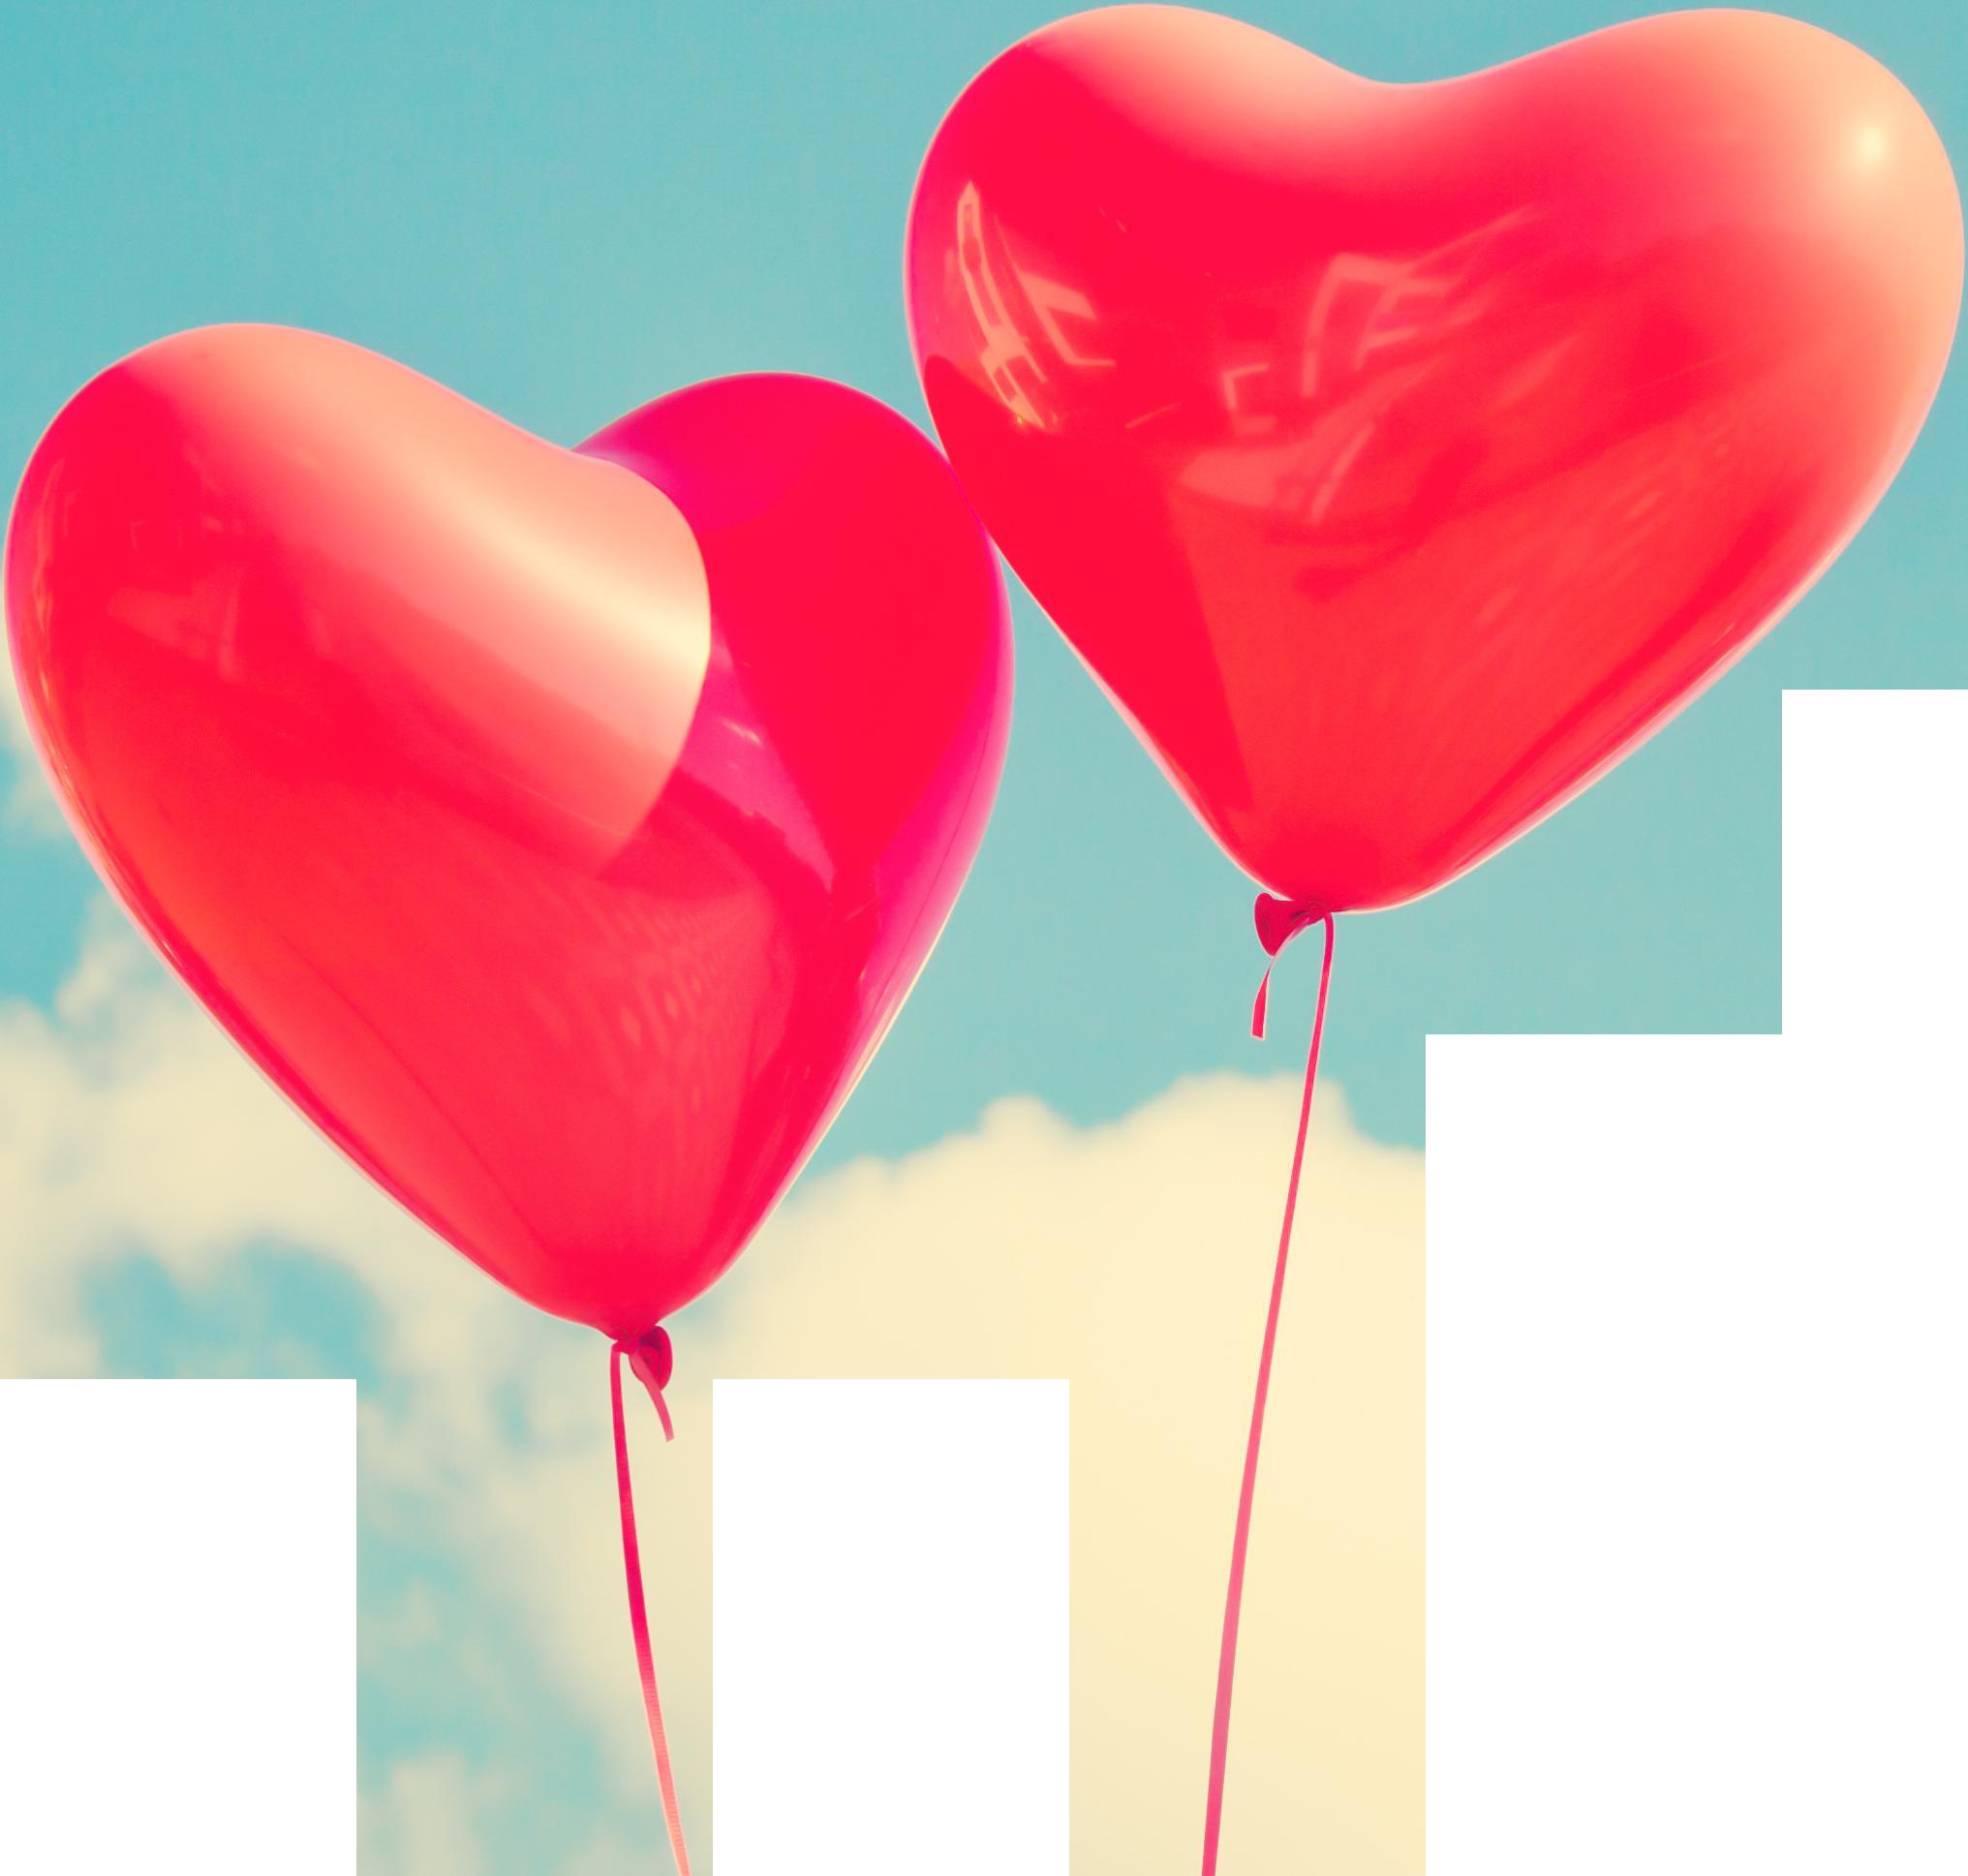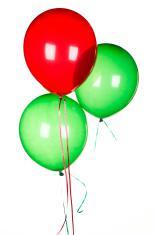The first image is the image on the left, the second image is the image on the right. Evaluate the accuracy of this statement regarding the images: "Each image shows exactly one aqua balloon next to one red balloon.". Is it true? Answer yes or no. No. The first image is the image on the left, the second image is the image on the right. Analyze the images presented: Is the assertion "Each image shows one round red balloon and one round green balloon side by side" valid? Answer yes or no. No. 